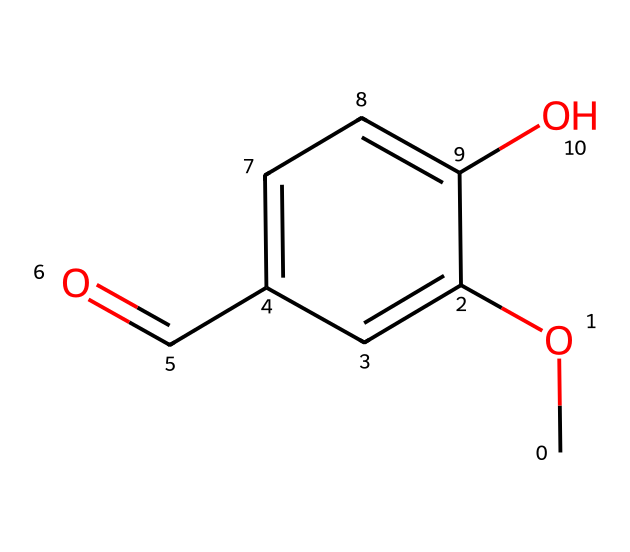How many carbon atoms are in vanillin? Count the number of carbon atoms (C) represented in the SMILES notation. Each 'C' represents a carbon atom, and from the structure, there are 8 carbon atoms total.
Answer: eight What functional groups are present in vanillin? Identify the functional groups by analyzing the structure. The chemical contains a methoxy group (–OCH3) and an aldehyde group (–CHO).
Answer: methoxy and aldehyde What is the molecular formula of vanillin? Use the visual representation to count the numbers of each type of atom: 8 carbon (C), 8 hydrogen (H), and 3 oxygen (O). This gives the formula C8H8O3.
Answer: C8H8O3 Which part of the chemical structure determines its sweetness? Evaluate the structure to identify components associated with flavor. The methyl ether group is linked to the sweet flavor in compounds like vanillin.
Answer: methyl ether group How many double bonds are in vanillin? Check the structure for any double bonds. There is one double bond in the aldehyde functional group and another in the aromatic ring, totaling two double bonds.
Answer: two Is vanillin a saturated or unsaturated compound? Analyze the structure to determine the saturation. The presence of double bonds in the structure indicates that it is unsaturated.
Answer: unsaturated What type of compound is vanillin classified as? Look at the overall structure and functional groups; vanillin is classified as an aromatic aldehyde because of its aromatic ring and aldehyde group.
Answer: aromatic aldehyde 